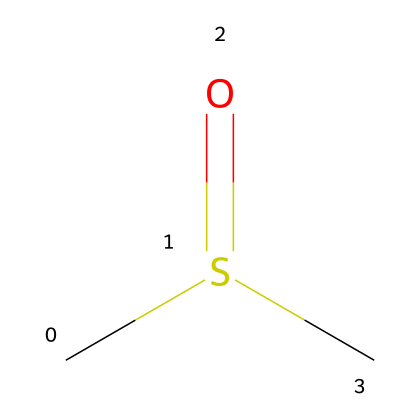What is the molecular formula of this compound? The SMILES representation shows two carbon (C) atoms, one sulfur (S) atom, and one oxygen (O) atom. By counting these, the molecular formula can be derived as C2H6OS.
Answer: C2H6OS How many carbon atoms are in this compound? The SMILES representation indicates there are two 'C' characters, which represent two carbon atoms.
Answer: 2 What type of bond connects the sulfur and oxygen? In the SMILES representation, the "=O" indicates a double bond between the sulfur (S) and oxygen (O) atoms.
Answer: double bond What functional group is present in this molecule? The presence of the "-S(=O)-" section in the SMILES indicates it contains a sulfoxide functional group.
Answer: sulfoxide What is the total number of hydrogen atoms in this compound? The structure contains six hydrogen (H) atoms as inferred from the two carbon atoms and the overall chemical arrangement in the SMILES.
Answer: 6 How does the sulfoxide structure affect the solubility of DMSO? The sulfoxide group, being polar due to the presence of sulfur and oxygen, increases DMSO's polarity, thus enhancing solubility in polar solvents.
Answer: increases polarity Is DMSO an organosulfur compound? DMSO contains sulfur in its structure, which categorizes it as an organosulfur compound.
Answer: yes 